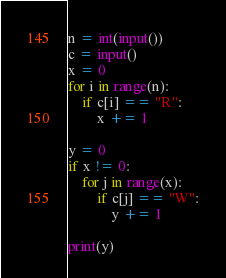Convert code to text. <code><loc_0><loc_0><loc_500><loc_500><_Python_>n = int(input())
c = input()
x = 0
for i in range(n):
    if c[i] == "R":
        x += 1

y = 0
if x != 0:
    for j in range(x):
        if c[j] == "W":
            y += 1

print(y)</code> 